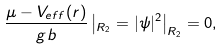Convert formula to latex. <formula><loc_0><loc_0><loc_500><loc_500>\frac { \mu - V _ { e f f } ( r ) } { g b } \left | _ { R _ { 2 } } = | \psi | ^ { 2 } \right | _ { R _ { 2 } } = 0 ,</formula> 